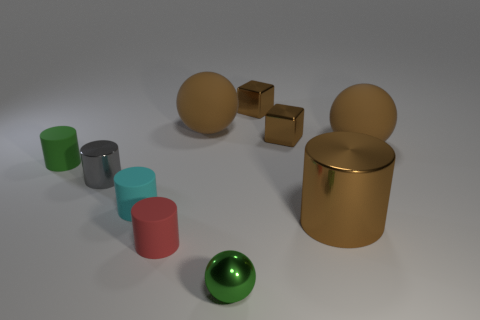Subtract 1 cylinders. How many cylinders are left? 4 Subtract all green cylinders. How many cylinders are left? 4 Subtract all tiny cyan cylinders. How many cylinders are left? 4 Subtract all brown balls. Subtract all green cylinders. How many balls are left? 1 Subtract all blocks. How many objects are left? 8 Add 4 cyan matte cylinders. How many cyan matte cylinders are left? 5 Add 8 small green spheres. How many small green spheres exist? 9 Subtract 0 cyan cubes. How many objects are left? 10 Subtract all large blue matte spheres. Subtract all big balls. How many objects are left? 8 